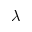<formula> <loc_0><loc_0><loc_500><loc_500>\lambda</formula> 